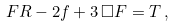<formula> <loc_0><loc_0><loc_500><loc_500>F R - 2 f + 3 \, \Box F = T \, ,</formula> 